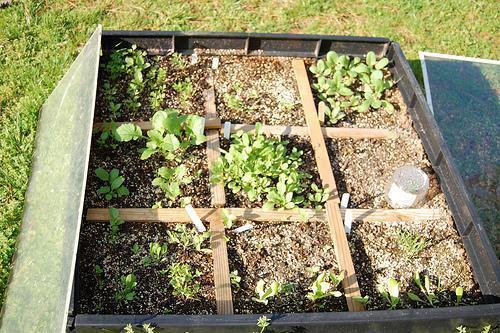How many segments is the garden made up of?
Give a very brief answer. 9. 